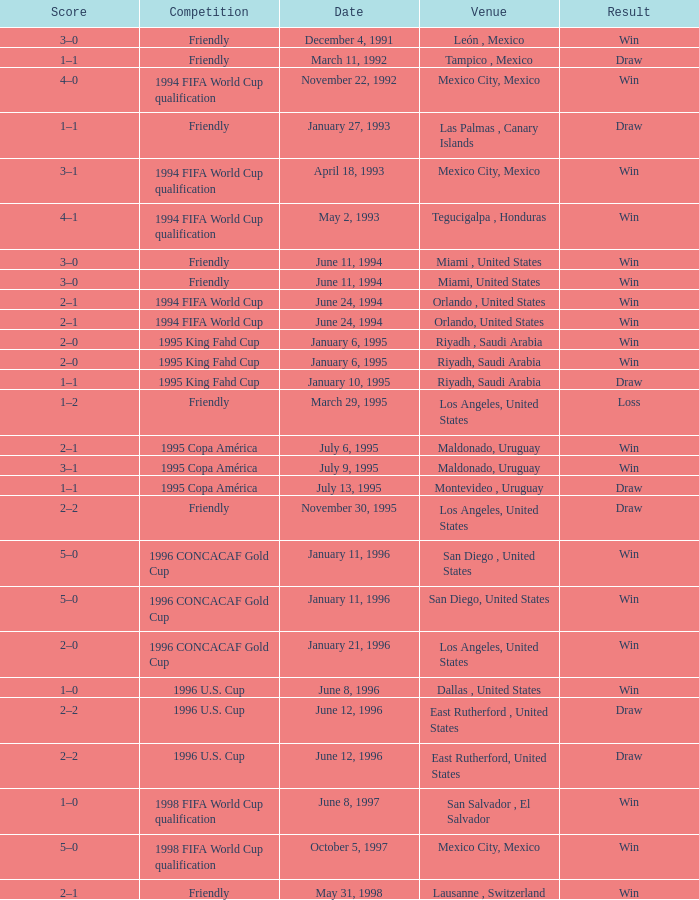What is Venue, when Date is "January 6, 1995"? Riyadh , Saudi Arabia, Riyadh, Saudi Arabia. 